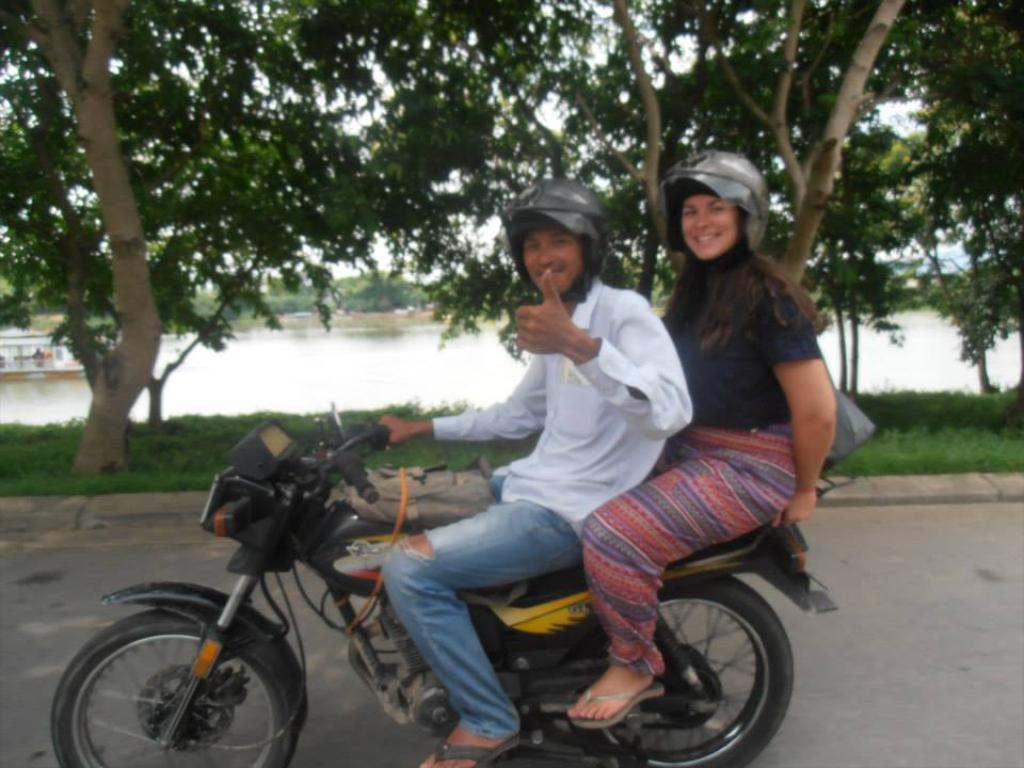How many people are in the image? There are people in the image, but the exact number is not specified. What are the people doing in the image? The people are sitting on a bike in the image. What type of natural environment can be seen in the image? There are trees visible in the image, which suggests a natural setting. What body of water is present in the image? There is a river in the image. What is the profit margin of the bike rental company in the image? There is no information about a bike rental company or profit margins in the image. Is there a jail visible in the image? No, there is no jail present in the image. 